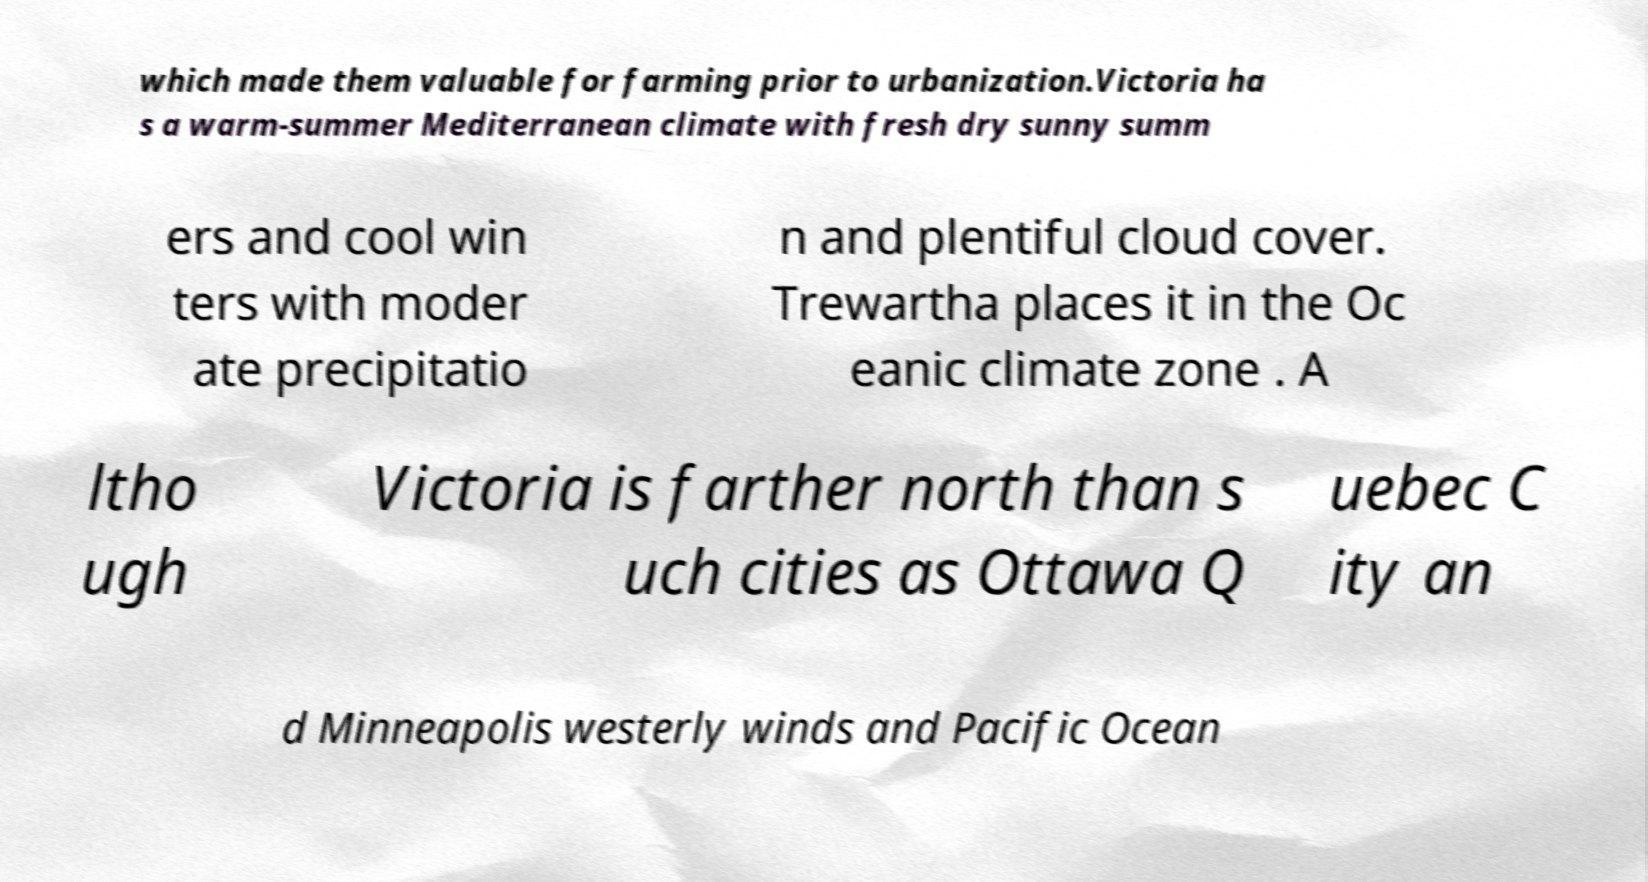Can you read and provide the text displayed in the image?This photo seems to have some interesting text. Can you extract and type it out for me? which made them valuable for farming prior to urbanization.Victoria ha s a warm-summer Mediterranean climate with fresh dry sunny summ ers and cool win ters with moder ate precipitatio n and plentiful cloud cover. Trewartha places it in the Oc eanic climate zone . A ltho ugh Victoria is farther north than s uch cities as Ottawa Q uebec C ity an d Minneapolis westerly winds and Pacific Ocean 